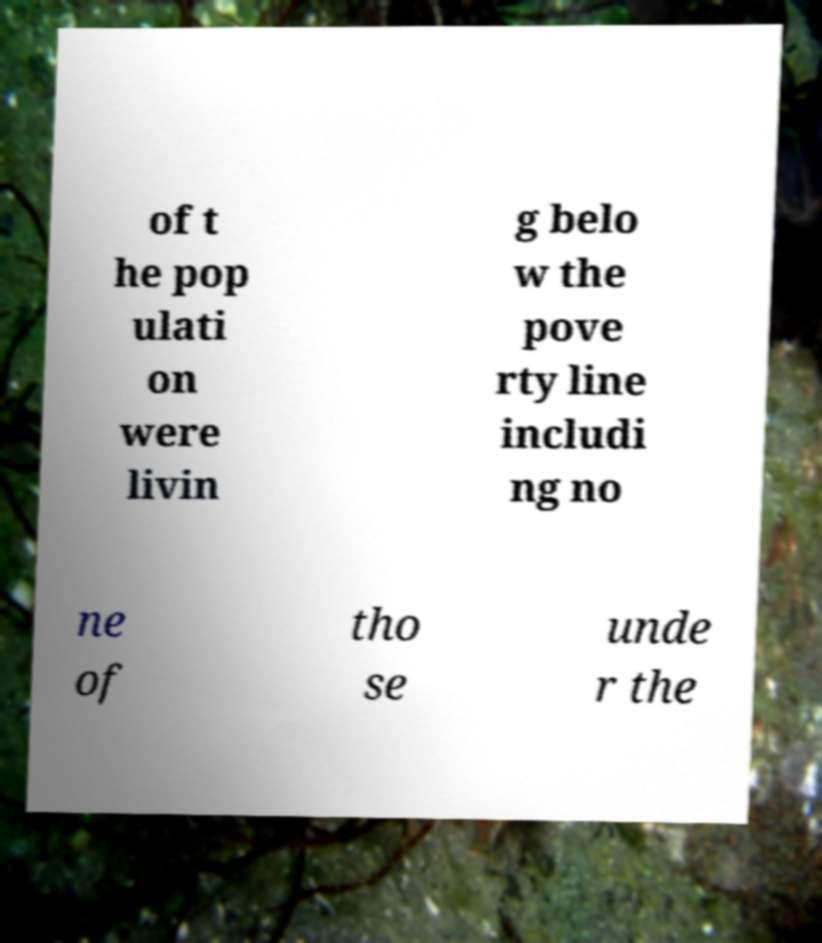Please read and relay the text visible in this image. What does it say? of t he pop ulati on were livin g belo w the pove rty line includi ng no ne of tho se unde r the 